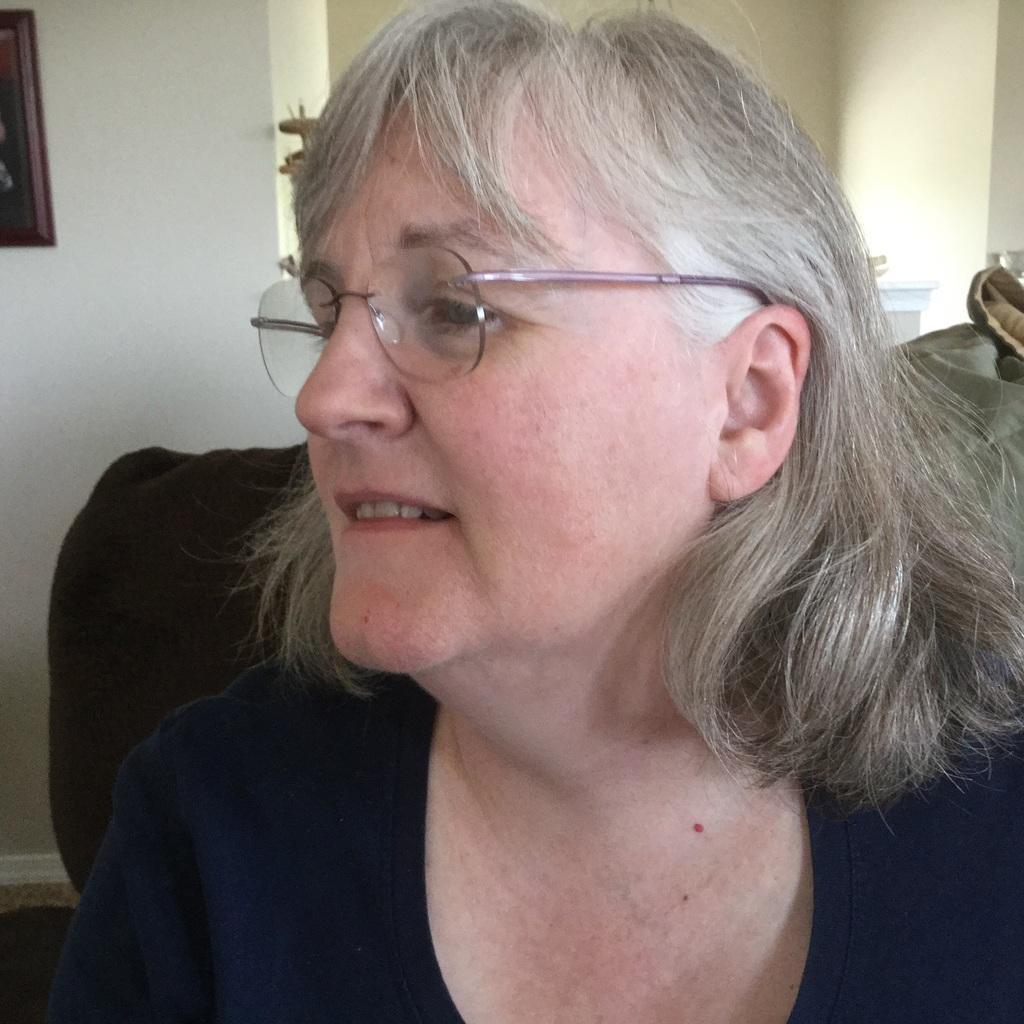Please provide a concise description of this image. This picture shows a woman seated on the chair and we see spectacles on her face and we see a photo frame on the wall. 